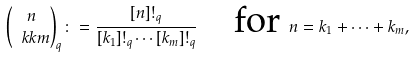<formula> <loc_0><loc_0><loc_500><loc_500>\binom { n } { \ k k m } _ { q } \colon = \frac { [ n ] ! _ { q } } { [ k _ { 1 } ] ! _ { q } \cdots [ k _ { m } ] ! _ { q } } \quad \text {for } n = k _ { 1 } + \dots + k _ { m } ,</formula> 